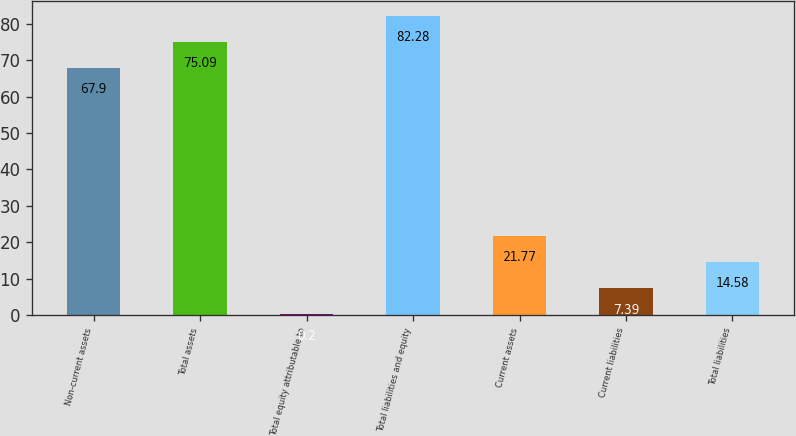Convert chart to OTSL. <chart><loc_0><loc_0><loc_500><loc_500><bar_chart><fcel>Non-current assets<fcel>Total assets<fcel>Total equity attributable to<fcel>Total liabilities and equity<fcel>Current assets<fcel>Current liabilities<fcel>Total liabilities<nl><fcel>67.9<fcel>75.09<fcel>0.2<fcel>82.28<fcel>21.77<fcel>7.39<fcel>14.58<nl></chart> 